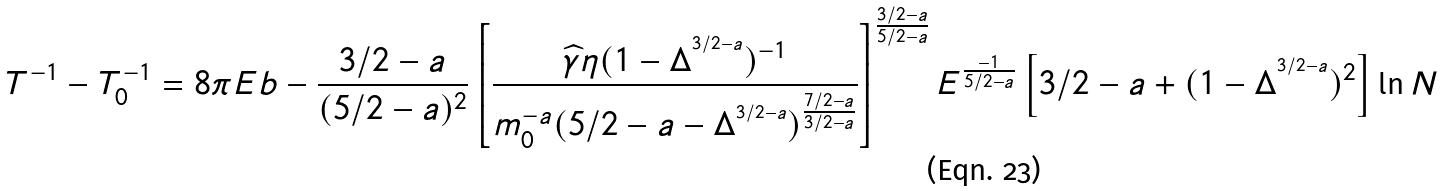Convert formula to latex. <formula><loc_0><loc_0><loc_500><loc_500>T ^ { - 1 } - T _ { 0 } ^ { - 1 } = 8 \pi E b - \frac { 3 / 2 - a } { ( 5 / 2 - a ) ^ { 2 } } \left [ \frac { \widehat { \gamma } \eta ( 1 - \Delta ^ { ^ { 3 / 2 - a } } ) ^ { - 1 } } { m _ { 0 } ^ { - a } ( 5 / 2 - a - \Delta ^ { ^ { 3 / 2 - a } } ) ^ { \frac { 7 / 2 - a } { 3 / 2 - a } } } \right ] ^ { \frac { 3 / 2 - a } { 5 / 2 - a } } E ^ { \frac { - 1 } { 5 / 2 - a } } \left [ 3 / 2 - a + ( 1 - \Delta ^ { ^ { 3 / 2 - a } } ) ^ { 2 } \right ] \ln N</formula> 